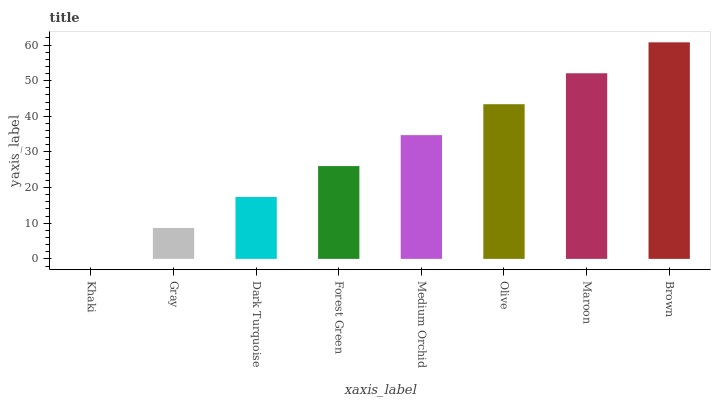Is Gray the minimum?
Answer yes or no. No. Is Gray the maximum?
Answer yes or no. No. Is Gray greater than Khaki?
Answer yes or no. Yes. Is Khaki less than Gray?
Answer yes or no. Yes. Is Khaki greater than Gray?
Answer yes or no. No. Is Gray less than Khaki?
Answer yes or no. No. Is Medium Orchid the high median?
Answer yes or no. Yes. Is Forest Green the low median?
Answer yes or no. Yes. Is Forest Green the high median?
Answer yes or no. No. Is Medium Orchid the low median?
Answer yes or no. No. 